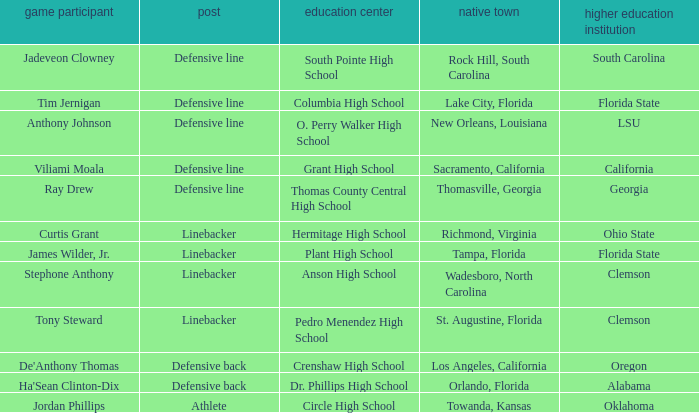Which player is from Tampa, Florida? James Wilder, Jr. 